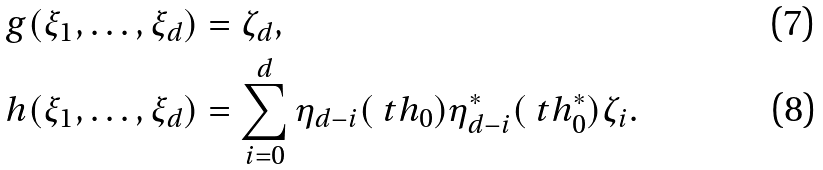<formula> <loc_0><loc_0><loc_500><loc_500>g ( \xi _ { 1 } , \dots , \xi _ { d } ) & = \zeta _ { d } , \\ h ( \xi _ { 1 } , \dots , \xi _ { d } ) & = \sum _ { i = 0 } ^ { d } \eta _ { d - i } ( \ t h _ { 0 } ) \eta ^ { * } _ { d - i } ( \ t h ^ { * } _ { 0 } ) \zeta _ { i } .</formula> 